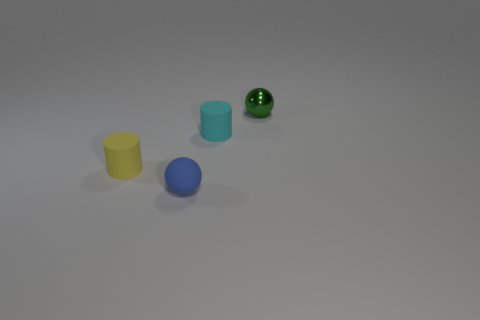Add 2 blue things. How many objects exist? 6 Subtract 0 red cylinders. How many objects are left? 4 Subtract all small matte blocks. Subtract all tiny green shiny things. How many objects are left? 3 Add 1 tiny metal things. How many tiny metal things are left? 2 Add 2 yellow things. How many yellow things exist? 3 